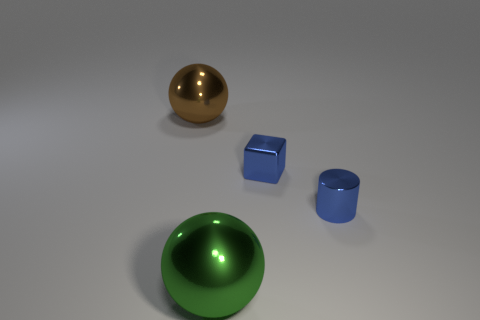Add 1 large yellow spheres. How many objects exist? 5 Subtract all red spheres. Subtract all purple cylinders. How many spheres are left? 2 Subtract all brown spheres. How many spheres are left? 1 Subtract all cylinders. How many objects are left? 3 Subtract 1 cylinders. How many cylinders are left? 0 Subtract all gray balls. How many purple cylinders are left? 0 Subtract all tiny blue metal objects. Subtract all small metallic blocks. How many objects are left? 1 Add 1 brown things. How many brown things are left? 2 Add 2 metal objects. How many metal objects exist? 6 Subtract 0 purple cylinders. How many objects are left? 4 